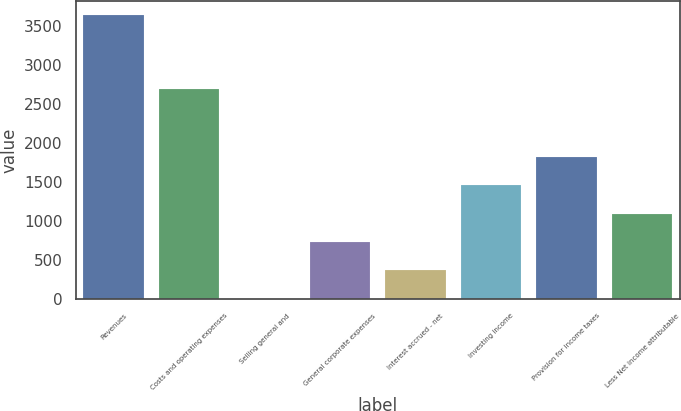Convert chart to OTSL. <chart><loc_0><loc_0><loc_500><loc_500><bar_chart><fcel>Revenues<fcel>Costs and operating expenses<fcel>Selling general and<fcel>General corporate expenses<fcel>Interest accrued - net<fcel>Investing income<fcel>Provision for income taxes<fcel>Less Net income attributable<nl><fcel>3635<fcel>2695<fcel>8<fcel>733.4<fcel>370.7<fcel>1458.8<fcel>1821.5<fcel>1096.1<nl></chart> 